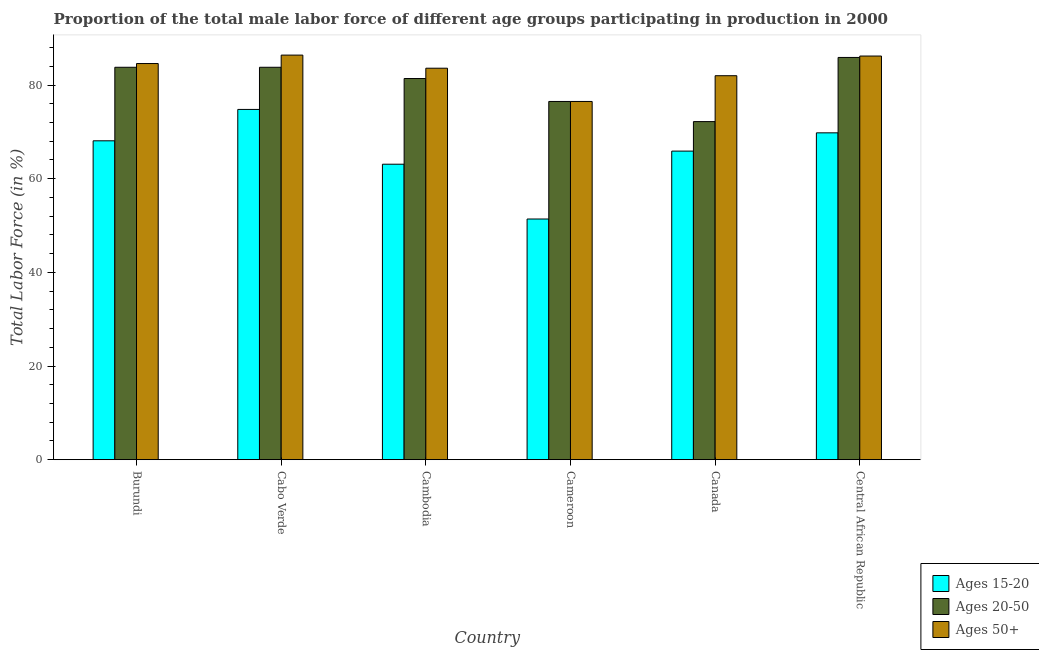How many different coloured bars are there?
Provide a short and direct response. 3. How many groups of bars are there?
Provide a succinct answer. 6. How many bars are there on the 4th tick from the left?
Give a very brief answer. 3. How many bars are there on the 1st tick from the right?
Provide a succinct answer. 3. What is the label of the 3rd group of bars from the left?
Your answer should be compact. Cambodia. What is the percentage of male labor force above age 50 in Central African Republic?
Give a very brief answer. 86.2. Across all countries, what is the maximum percentage of male labor force above age 50?
Provide a succinct answer. 86.4. Across all countries, what is the minimum percentage of male labor force above age 50?
Your answer should be very brief. 76.5. In which country was the percentage of male labor force within the age group 15-20 maximum?
Your response must be concise. Cabo Verde. In which country was the percentage of male labor force within the age group 20-50 minimum?
Give a very brief answer. Canada. What is the total percentage of male labor force within the age group 15-20 in the graph?
Your response must be concise. 393.1. What is the difference between the percentage of male labor force within the age group 20-50 in Cabo Verde and that in Cambodia?
Provide a succinct answer. 2.4. What is the difference between the percentage of male labor force within the age group 15-20 in Burundi and the percentage of male labor force above age 50 in Cabo Verde?
Offer a terse response. -18.3. What is the average percentage of male labor force within the age group 20-50 per country?
Keep it short and to the point. 80.6. What is the difference between the percentage of male labor force within the age group 20-50 and percentage of male labor force within the age group 15-20 in Central African Republic?
Provide a succinct answer. 16.1. What is the ratio of the percentage of male labor force within the age group 20-50 in Cameroon to that in Canada?
Provide a short and direct response. 1.06. What is the difference between the highest and the second highest percentage of male labor force within the age group 15-20?
Offer a very short reply. 5. What is the difference between the highest and the lowest percentage of male labor force above age 50?
Offer a terse response. 9.9. Is the sum of the percentage of male labor force above age 50 in Cameroon and Central African Republic greater than the maximum percentage of male labor force within the age group 15-20 across all countries?
Your response must be concise. Yes. What does the 3rd bar from the left in Canada represents?
Your response must be concise. Ages 50+. What does the 3rd bar from the right in Central African Republic represents?
Ensure brevity in your answer.  Ages 15-20. How many countries are there in the graph?
Provide a succinct answer. 6. How many legend labels are there?
Offer a very short reply. 3. How are the legend labels stacked?
Keep it short and to the point. Vertical. What is the title of the graph?
Provide a succinct answer. Proportion of the total male labor force of different age groups participating in production in 2000. What is the label or title of the X-axis?
Ensure brevity in your answer.  Country. What is the label or title of the Y-axis?
Your answer should be compact. Total Labor Force (in %). What is the Total Labor Force (in %) in Ages 15-20 in Burundi?
Provide a succinct answer. 68.1. What is the Total Labor Force (in %) in Ages 20-50 in Burundi?
Give a very brief answer. 83.8. What is the Total Labor Force (in %) in Ages 50+ in Burundi?
Give a very brief answer. 84.6. What is the Total Labor Force (in %) in Ages 15-20 in Cabo Verde?
Offer a terse response. 74.8. What is the Total Labor Force (in %) in Ages 20-50 in Cabo Verde?
Ensure brevity in your answer.  83.8. What is the Total Labor Force (in %) of Ages 50+ in Cabo Verde?
Make the answer very short. 86.4. What is the Total Labor Force (in %) in Ages 15-20 in Cambodia?
Provide a short and direct response. 63.1. What is the Total Labor Force (in %) of Ages 20-50 in Cambodia?
Offer a very short reply. 81.4. What is the Total Labor Force (in %) of Ages 50+ in Cambodia?
Provide a short and direct response. 83.6. What is the Total Labor Force (in %) in Ages 15-20 in Cameroon?
Your answer should be compact. 51.4. What is the Total Labor Force (in %) in Ages 20-50 in Cameroon?
Keep it short and to the point. 76.5. What is the Total Labor Force (in %) in Ages 50+ in Cameroon?
Keep it short and to the point. 76.5. What is the Total Labor Force (in %) in Ages 15-20 in Canada?
Offer a terse response. 65.9. What is the Total Labor Force (in %) in Ages 20-50 in Canada?
Give a very brief answer. 72.2. What is the Total Labor Force (in %) in Ages 50+ in Canada?
Your response must be concise. 82. What is the Total Labor Force (in %) of Ages 15-20 in Central African Republic?
Provide a succinct answer. 69.8. What is the Total Labor Force (in %) in Ages 20-50 in Central African Republic?
Ensure brevity in your answer.  85.9. What is the Total Labor Force (in %) in Ages 50+ in Central African Republic?
Provide a short and direct response. 86.2. Across all countries, what is the maximum Total Labor Force (in %) of Ages 15-20?
Keep it short and to the point. 74.8. Across all countries, what is the maximum Total Labor Force (in %) of Ages 20-50?
Provide a short and direct response. 85.9. Across all countries, what is the maximum Total Labor Force (in %) in Ages 50+?
Give a very brief answer. 86.4. Across all countries, what is the minimum Total Labor Force (in %) in Ages 15-20?
Provide a short and direct response. 51.4. Across all countries, what is the minimum Total Labor Force (in %) in Ages 20-50?
Your answer should be compact. 72.2. Across all countries, what is the minimum Total Labor Force (in %) of Ages 50+?
Your answer should be compact. 76.5. What is the total Total Labor Force (in %) in Ages 15-20 in the graph?
Ensure brevity in your answer.  393.1. What is the total Total Labor Force (in %) in Ages 20-50 in the graph?
Your response must be concise. 483.6. What is the total Total Labor Force (in %) in Ages 50+ in the graph?
Ensure brevity in your answer.  499.3. What is the difference between the Total Labor Force (in %) in Ages 20-50 in Burundi and that in Cambodia?
Give a very brief answer. 2.4. What is the difference between the Total Labor Force (in %) of Ages 15-20 in Burundi and that in Cameroon?
Keep it short and to the point. 16.7. What is the difference between the Total Labor Force (in %) of Ages 20-50 in Burundi and that in Cameroon?
Your answer should be very brief. 7.3. What is the difference between the Total Labor Force (in %) of Ages 50+ in Burundi and that in Canada?
Your response must be concise. 2.6. What is the difference between the Total Labor Force (in %) of Ages 20-50 in Burundi and that in Central African Republic?
Ensure brevity in your answer.  -2.1. What is the difference between the Total Labor Force (in %) of Ages 50+ in Burundi and that in Central African Republic?
Provide a short and direct response. -1.6. What is the difference between the Total Labor Force (in %) of Ages 15-20 in Cabo Verde and that in Cambodia?
Provide a succinct answer. 11.7. What is the difference between the Total Labor Force (in %) of Ages 50+ in Cabo Verde and that in Cambodia?
Ensure brevity in your answer.  2.8. What is the difference between the Total Labor Force (in %) of Ages 15-20 in Cabo Verde and that in Cameroon?
Provide a short and direct response. 23.4. What is the difference between the Total Labor Force (in %) of Ages 20-50 in Cabo Verde and that in Cameroon?
Give a very brief answer. 7.3. What is the difference between the Total Labor Force (in %) in Ages 50+ in Cabo Verde and that in Cameroon?
Keep it short and to the point. 9.9. What is the difference between the Total Labor Force (in %) of Ages 15-20 in Cabo Verde and that in Canada?
Keep it short and to the point. 8.9. What is the difference between the Total Labor Force (in %) of Ages 50+ in Cabo Verde and that in Canada?
Make the answer very short. 4.4. What is the difference between the Total Labor Force (in %) of Ages 15-20 in Cabo Verde and that in Central African Republic?
Give a very brief answer. 5. What is the difference between the Total Labor Force (in %) of Ages 15-20 in Cambodia and that in Cameroon?
Your answer should be compact. 11.7. What is the difference between the Total Labor Force (in %) of Ages 20-50 in Cambodia and that in Cameroon?
Give a very brief answer. 4.9. What is the difference between the Total Labor Force (in %) in Ages 50+ in Cambodia and that in Cameroon?
Your response must be concise. 7.1. What is the difference between the Total Labor Force (in %) in Ages 15-20 in Cambodia and that in Canada?
Your response must be concise. -2.8. What is the difference between the Total Labor Force (in %) in Ages 15-20 in Cambodia and that in Central African Republic?
Ensure brevity in your answer.  -6.7. What is the difference between the Total Labor Force (in %) in Ages 20-50 in Cambodia and that in Central African Republic?
Give a very brief answer. -4.5. What is the difference between the Total Labor Force (in %) in Ages 50+ in Cambodia and that in Central African Republic?
Offer a very short reply. -2.6. What is the difference between the Total Labor Force (in %) of Ages 15-20 in Cameroon and that in Canada?
Provide a succinct answer. -14.5. What is the difference between the Total Labor Force (in %) of Ages 50+ in Cameroon and that in Canada?
Provide a succinct answer. -5.5. What is the difference between the Total Labor Force (in %) in Ages 15-20 in Cameroon and that in Central African Republic?
Give a very brief answer. -18.4. What is the difference between the Total Labor Force (in %) of Ages 20-50 in Cameroon and that in Central African Republic?
Offer a very short reply. -9.4. What is the difference between the Total Labor Force (in %) in Ages 50+ in Cameroon and that in Central African Republic?
Offer a terse response. -9.7. What is the difference between the Total Labor Force (in %) of Ages 15-20 in Canada and that in Central African Republic?
Ensure brevity in your answer.  -3.9. What is the difference between the Total Labor Force (in %) in Ages 20-50 in Canada and that in Central African Republic?
Your answer should be very brief. -13.7. What is the difference between the Total Labor Force (in %) of Ages 15-20 in Burundi and the Total Labor Force (in %) of Ages 20-50 in Cabo Verde?
Your answer should be very brief. -15.7. What is the difference between the Total Labor Force (in %) of Ages 15-20 in Burundi and the Total Labor Force (in %) of Ages 50+ in Cabo Verde?
Give a very brief answer. -18.3. What is the difference between the Total Labor Force (in %) in Ages 20-50 in Burundi and the Total Labor Force (in %) in Ages 50+ in Cabo Verde?
Offer a terse response. -2.6. What is the difference between the Total Labor Force (in %) of Ages 15-20 in Burundi and the Total Labor Force (in %) of Ages 50+ in Cambodia?
Provide a short and direct response. -15.5. What is the difference between the Total Labor Force (in %) of Ages 20-50 in Burundi and the Total Labor Force (in %) of Ages 50+ in Cambodia?
Your answer should be very brief. 0.2. What is the difference between the Total Labor Force (in %) of Ages 15-20 in Burundi and the Total Labor Force (in %) of Ages 20-50 in Canada?
Keep it short and to the point. -4.1. What is the difference between the Total Labor Force (in %) of Ages 15-20 in Burundi and the Total Labor Force (in %) of Ages 50+ in Canada?
Your answer should be compact. -13.9. What is the difference between the Total Labor Force (in %) in Ages 15-20 in Burundi and the Total Labor Force (in %) in Ages 20-50 in Central African Republic?
Make the answer very short. -17.8. What is the difference between the Total Labor Force (in %) of Ages 15-20 in Burundi and the Total Labor Force (in %) of Ages 50+ in Central African Republic?
Keep it short and to the point. -18.1. What is the difference between the Total Labor Force (in %) of Ages 20-50 in Burundi and the Total Labor Force (in %) of Ages 50+ in Central African Republic?
Your answer should be very brief. -2.4. What is the difference between the Total Labor Force (in %) in Ages 15-20 in Cabo Verde and the Total Labor Force (in %) in Ages 20-50 in Cambodia?
Your answer should be compact. -6.6. What is the difference between the Total Labor Force (in %) of Ages 15-20 in Cabo Verde and the Total Labor Force (in %) of Ages 50+ in Cambodia?
Your response must be concise. -8.8. What is the difference between the Total Labor Force (in %) in Ages 20-50 in Cabo Verde and the Total Labor Force (in %) in Ages 50+ in Cambodia?
Give a very brief answer. 0.2. What is the difference between the Total Labor Force (in %) of Ages 15-20 in Cabo Verde and the Total Labor Force (in %) of Ages 20-50 in Cameroon?
Make the answer very short. -1.7. What is the difference between the Total Labor Force (in %) of Ages 15-20 in Cabo Verde and the Total Labor Force (in %) of Ages 50+ in Cameroon?
Your answer should be compact. -1.7. What is the difference between the Total Labor Force (in %) in Ages 15-20 in Cabo Verde and the Total Labor Force (in %) in Ages 20-50 in Canada?
Offer a terse response. 2.6. What is the difference between the Total Labor Force (in %) in Ages 20-50 in Cabo Verde and the Total Labor Force (in %) in Ages 50+ in Canada?
Your answer should be compact. 1.8. What is the difference between the Total Labor Force (in %) of Ages 15-20 in Cabo Verde and the Total Labor Force (in %) of Ages 50+ in Central African Republic?
Offer a very short reply. -11.4. What is the difference between the Total Labor Force (in %) of Ages 20-50 in Cabo Verde and the Total Labor Force (in %) of Ages 50+ in Central African Republic?
Give a very brief answer. -2.4. What is the difference between the Total Labor Force (in %) of Ages 15-20 in Cambodia and the Total Labor Force (in %) of Ages 50+ in Cameroon?
Keep it short and to the point. -13.4. What is the difference between the Total Labor Force (in %) of Ages 20-50 in Cambodia and the Total Labor Force (in %) of Ages 50+ in Cameroon?
Your answer should be very brief. 4.9. What is the difference between the Total Labor Force (in %) in Ages 15-20 in Cambodia and the Total Labor Force (in %) in Ages 20-50 in Canada?
Give a very brief answer. -9.1. What is the difference between the Total Labor Force (in %) of Ages 15-20 in Cambodia and the Total Labor Force (in %) of Ages 50+ in Canada?
Provide a succinct answer. -18.9. What is the difference between the Total Labor Force (in %) of Ages 20-50 in Cambodia and the Total Labor Force (in %) of Ages 50+ in Canada?
Ensure brevity in your answer.  -0.6. What is the difference between the Total Labor Force (in %) in Ages 15-20 in Cambodia and the Total Labor Force (in %) in Ages 20-50 in Central African Republic?
Provide a short and direct response. -22.8. What is the difference between the Total Labor Force (in %) in Ages 15-20 in Cambodia and the Total Labor Force (in %) in Ages 50+ in Central African Republic?
Provide a short and direct response. -23.1. What is the difference between the Total Labor Force (in %) in Ages 20-50 in Cambodia and the Total Labor Force (in %) in Ages 50+ in Central African Republic?
Your answer should be compact. -4.8. What is the difference between the Total Labor Force (in %) in Ages 15-20 in Cameroon and the Total Labor Force (in %) in Ages 20-50 in Canada?
Ensure brevity in your answer.  -20.8. What is the difference between the Total Labor Force (in %) in Ages 15-20 in Cameroon and the Total Labor Force (in %) in Ages 50+ in Canada?
Offer a very short reply. -30.6. What is the difference between the Total Labor Force (in %) of Ages 15-20 in Cameroon and the Total Labor Force (in %) of Ages 20-50 in Central African Republic?
Keep it short and to the point. -34.5. What is the difference between the Total Labor Force (in %) in Ages 15-20 in Cameroon and the Total Labor Force (in %) in Ages 50+ in Central African Republic?
Provide a short and direct response. -34.8. What is the difference between the Total Labor Force (in %) of Ages 15-20 in Canada and the Total Labor Force (in %) of Ages 50+ in Central African Republic?
Give a very brief answer. -20.3. What is the difference between the Total Labor Force (in %) of Ages 20-50 in Canada and the Total Labor Force (in %) of Ages 50+ in Central African Republic?
Give a very brief answer. -14. What is the average Total Labor Force (in %) in Ages 15-20 per country?
Make the answer very short. 65.52. What is the average Total Labor Force (in %) of Ages 20-50 per country?
Provide a succinct answer. 80.6. What is the average Total Labor Force (in %) of Ages 50+ per country?
Your answer should be compact. 83.22. What is the difference between the Total Labor Force (in %) of Ages 15-20 and Total Labor Force (in %) of Ages 20-50 in Burundi?
Your response must be concise. -15.7. What is the difference between the Total Labor Force (in %) of Ages 15-20 and Total Labor Force (in %) of Ages 50+ in Burundi?
Your answer should be compact. -16.5. What is the difference between the Total Labor Force (in %) in Ages 15-20 and Total Labor Force (in %) in Ages 50+ in Cabo Verde?
Your answer should be compact. -11.6. What is the difference between the Total Labor Force (in %) in Ages 15-20 and Total Labor Force (in %) in Ages 20-50 in Cambodia?
Your response must be concise. -18.3. What is the difference between the Total Labor Force (in %) of Ages 15-20 and Total Labor Force (in %) of Ages 50+ in Cambodia?
Your response must be concise. -20.5. What is the difference between the Total Labor Force (in %) in Ages 20-50 and Total Labor Force (in %) in Ages 50+ in Cambodia?
Your answer should be very brief. -2.2. What is the difference between the Total Labor Force (in %) of Ages 15-20 and Total Labor Force (in %) of Ages 20-50 in Cameroon?
Make the answer very short. -25.1. What is the difference between the Total Labor Force (in %) in Ages 15-20 and Total Labor Force (in %) in Ages 50+ in Cameroon?
Make the answer very short. -25.1. What is the difference between the Total Labor Force (in %) in Ages 20-50 and Total Labor Force (in %) in Ages 50+ in Cameroon?
Provide a succinct answer. 0. What is the difference between the Total Labor Force (in %) of Ages 15-20 and Total Labor Force (in %) of Ages 20-50 in Canada?
Offer a very short reply. -6.3. What is the difference between the Total Labor Force (in %) of Ages 15-20 and Total Labor Force (in %) of Ages 50+ in Canada?
Provide a succinct answer. -16.1. What is the difference between the Total Labor Force (in %) of Ages 20-50 and Total Labor Force (in %) of Ages 50+ in Canada?
Your answer should be very brief. -9.8. What is the difference between the Total Labor Force (in %) in Ages 15-20 and Total Labor Force (in %) in Ages 20-50 in Central African Republic?
Provide a succinct answer. -16.1. What is the difference between the Total Labor Force (in %) of Ages 15-20 and Total Labor Force (in %) of Ages 50+ in Central African Republic?
Your response must be concise. -16.4. What is the ratio of the Total Labor Force (in %) of Ages 15-20 in Burundi to that in Cabo Verde?
Keep it short and to the point. 0.91. What is the ratio of the Total Labor Force (in %) in Ages 50+ in Burundi to that in Cabo Verde?
Offer a terse response. 0.98. What is the ratio of the Total Labor Force (in %) of Ages 15-20 in Burundi to that in Cambodia?
Make the answer very short. 1.08. What is the ratio of the Total Labor Force (in %) of Ages 20-50 in Burundi to that in Cambodia?
Provide a short and direct response. 1.03. What is the ratio of the Total Labor Force (in %) in Ages 15-20 in Burundi to that in Cameroon?
Your answer should be compact. 1.32. What is the ratio of the Total Labor Force (in %) of Ages 20-50 in Burundi to that in Cameroon?
Ensure brevity in your answer.  1.1. What is the ratio of the Total Labor Force (in %) in Ages 50+ in Burundi to that in Cameroon?
Keep it short and to the point. 1.11. What is the ratio of the Total Labor Force (in %) in Ages 15-20 in Burundi to that in Canada?
Your answer should be very brief. 1.03. What is the ratio of the Total Labor Force (in %) of Ages 20-50 in Burundi to that in Canada?
Your response must be concise. 1.16. What is the ratio of the Total Labor Force (in %) of Ages 50+ in Burundi to that in Canada?
Your response must be concise. 1.03. What is the ratio of the Total Labor Force (in %) in Ages 15-20 in Burundi to that in Central African Republic?
Offer a terse response. 0.98. What is the ratio of the Total Labor Force (in %) of Ages 20-50 in Burundi to that in Central African Republic?
Keep it short and to the point. 0.98. What is the ratio of the Total Labor Force (in %) in Ages 50+ in Burundi to that in Central African Republic?
Ensure brevity in your answer.  0.98. What is the ratio of the Total Labor Force (in %) of Ages 15-20 in Cabo Verde to that in Cambodia?
Offer a terse response. 1.19. What is the ratio of the Total Labor Force (in %) of Ages 20-50 in Cabo Verde to that in Cambodia?
Provide a short and direct response. 1.03. What is the ratio of the Total Labor Force (in %) in Ages 50+ in Cabo Verde to that in Cambodia?
Make the answer very short. 1.03. What is the ratio of the Total Labor Force (in %) of Ages 15-20 in Cabo Verde to that in Cameroon?
Offer a very short reply. 1.46. What is the ratio of the Total Labor Force (in %) of Ages 20-50 in Cabo Verde to that in Cameroon?
Your answer should be very brief. 1.1. What is the ratio of the Total Labor Force (in %) of Ages 50+ in Cabo Verde to that in Cameroon?
Your answer should be compact. 1.13. What is the ratio of the Total Labor Force (in %) of Ages 15-20 in Cabo Verde to that in Canada?
Your answer should be very brief. 1.14. What is the ratio of the Total Labor Force (in %) in Ages 20-50 in Cabo Verde to that in Canada?
Offer a terse response. 1.16. What is the ratio of the Total Labor Force (in %) in Ages 50+ in Cabo Verde to that in Canada?
Provide a short and direct response. 1.05. What is the ratio of the Total Labor Force (in %) in Ages 15-20 in Cabo Verde to that in Central African Republic?
Your answer should be very brief. 1.07. What is the ratio of the Total Labor Force (in %) of Ages 20-50 in Cabo Verde to that in Central African Republic?
Give a very brief answer. 0.98. What is the ratio of the Total Labor Force (in %) of Ages 50+ in Cabo Verde to that in Central African Republic?
Give a very brief answer. 1. What is the ratio of the Total Labor Force (in %) of Ages 15-20 in Cambodia to that in Cameroon?
Offer a terse response. 1.23. What is the ratio of the Total Labor Force (in %) in Ages 20-50 in Cambodia to that in Cameroon?
Provide a short and direct response. 1.06. What is the ratio of the Total Labor Force (in %) of Ages 50+ in Cambodia to that in Cameroon?
Your answer should be compact. 1.09. What is the ratio of the Total Labor Force (in %) of Ages 15-20 in Cambodia to that in Canada?
Offer a very short reply. 0.96. What is the ratio of the Total Labor Force (in %) in Ages 20-50 in Cambodia to that in Canada?
Keep it short and to the point. 1.13. What is the ratio of the Total Labor Force (in %) of Ages 50+ in Cambodia to that in Canada?
Provide a short and direct response. 1.02. What is the ratio of the Total Labor Force (in %) in Ages 15-20 in Cambodia to that in Central African Republic?
Offer a terse response. 0.9. What is the ratio of the Total Labor Force (in %) of Ages 20-50 in Cambodia to that in Central African Republic?
Offer a terse response. 0.95. What is the ratio of the Total Labor Force (in %) in Ages 50+ in Cambodia to that in Central African Republic?
Provide a succinct answer. 0.97. What is the ratio of the Total Labor Force (in %) of Ages 15-20 in Cameroon to that in Canada?
Your answer should be compact. 0.78. What is the ratio of the Total Labor Force (in %) of Ages 20-50 in Cameroon to that in Canada?
Your answer should be very brief. 1.06. What is the ratio of the Total Labor Force (in %) in Ages 50+ in Cameroon to that in Canada?
Offer a terse response. 0.93. What is the ratio of the Total Labor Force (in %) of Ages 15-20 in Cameroon to that in Central African Republic?
Ensure brevity in your answer.  0.74. What is the ratio of the Total Labor Force (in %) of Ages 20-50 in Cameroon to that in Central African Republic?
Provide a short and direct response. 0.89. What is the ratio of the Total Labor Force (in %) of Ages 50+ in Cameroon to that in Central African Republic?
Provide a short and direct response. 0.89. What is the ratio of the Total Labor Force (in %) of Ages 15-20 in Canada to that in Central African Republic?
Ensure brevity in your answer.  0.94. What is the ratio of the Total Labor Force (in %) in Ages 20-50 in Canada to that in Central African Republic?
Your answer should be compact. 0.84. What is the ratio of the Total Labor Force (in %) in Ages 50+ in Canada to that in Central African Republic?
Give a very brief answer. 0.95. What is the difference between the highest and the second highest Total Labor Force (in %) of Ages 15-20?
Your answer should be compact. 5. What is the difference between the highest and the lowest Total Labor Force (in %) in Ages 15-20?
Your response must be concise. 23.4. 